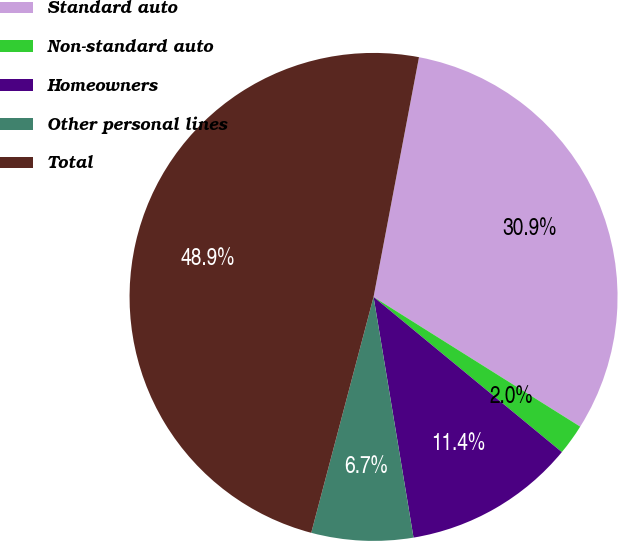Convert chart. <chart><loc_0><loc_0><loc_500><loc_500><pie_chart><fcel>Standard auto<fcel>Non-standard auto<fcel>Homeowners<fcel>Other personal lines<fcel>Total<nl><fcel>30.94%<fcel>2.05%<fcel>11.41%<fcel>6.73%<fcel>48.87%<nl></chart> 